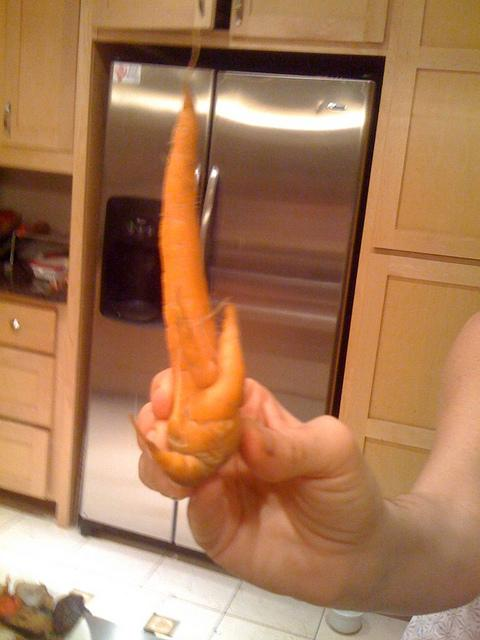What food category is this object in?

Choices:
A) grain
B) fruit
C) vegetable
D) sweet vegetable 